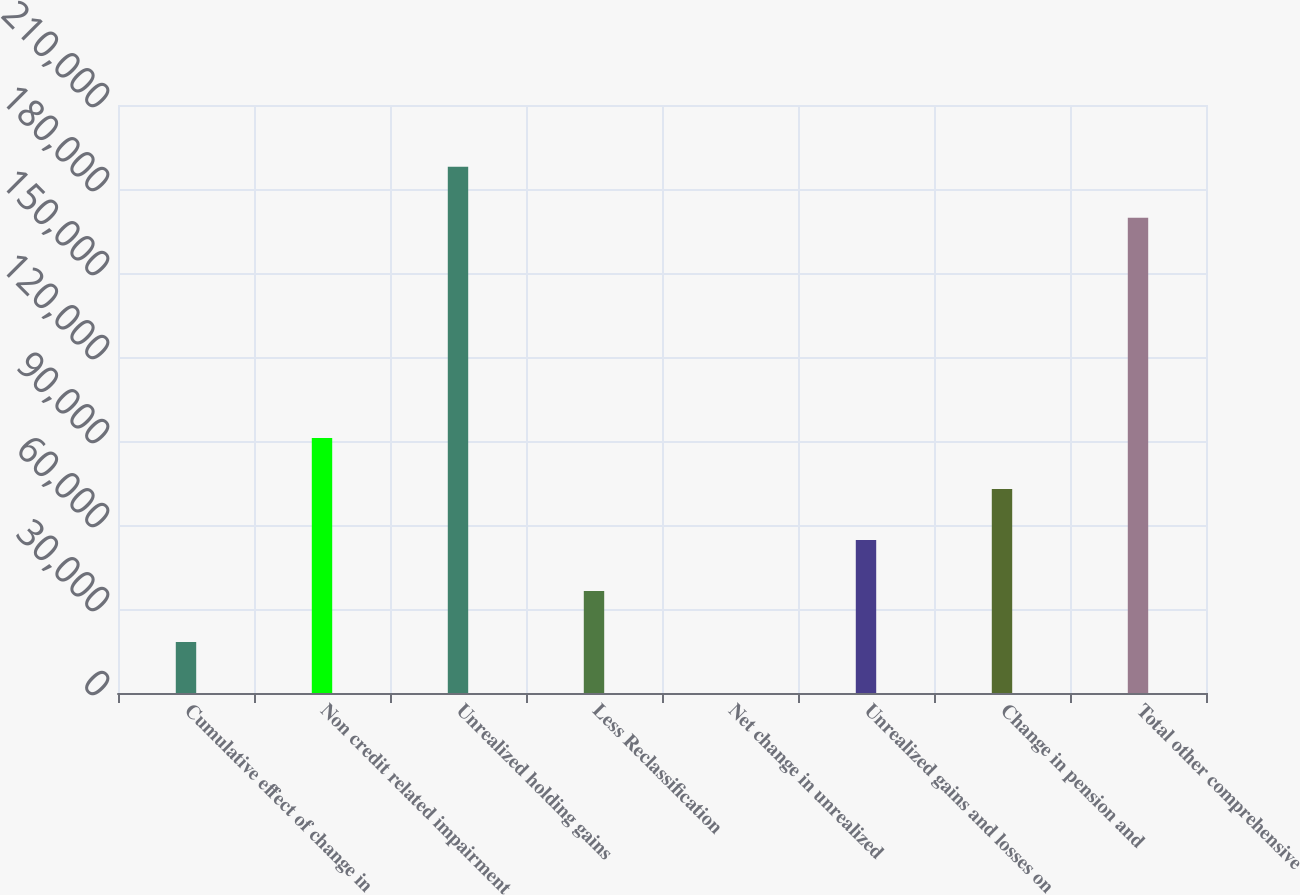Convert chart to OTSL. <chart><loc_0><loc_0><loc_500><loc_500><bar_chart><fcel>Cumulative effect of change in<fcel>Non credit related impairment<fcel>Unrealized holding gains<fcel>Less Reclassification<fcel>Net change in unrealized<fcel>Unrealized gains and losses on<fcel>Change in pension and<fcel>Total other comprehensive<nl><fcel>18217.4<fcel>91059<fcel>187918<fcel>36427.8<fcel>7<fcel>54638.2<fcel>72848.6<fcel>169708<nl></chart> 